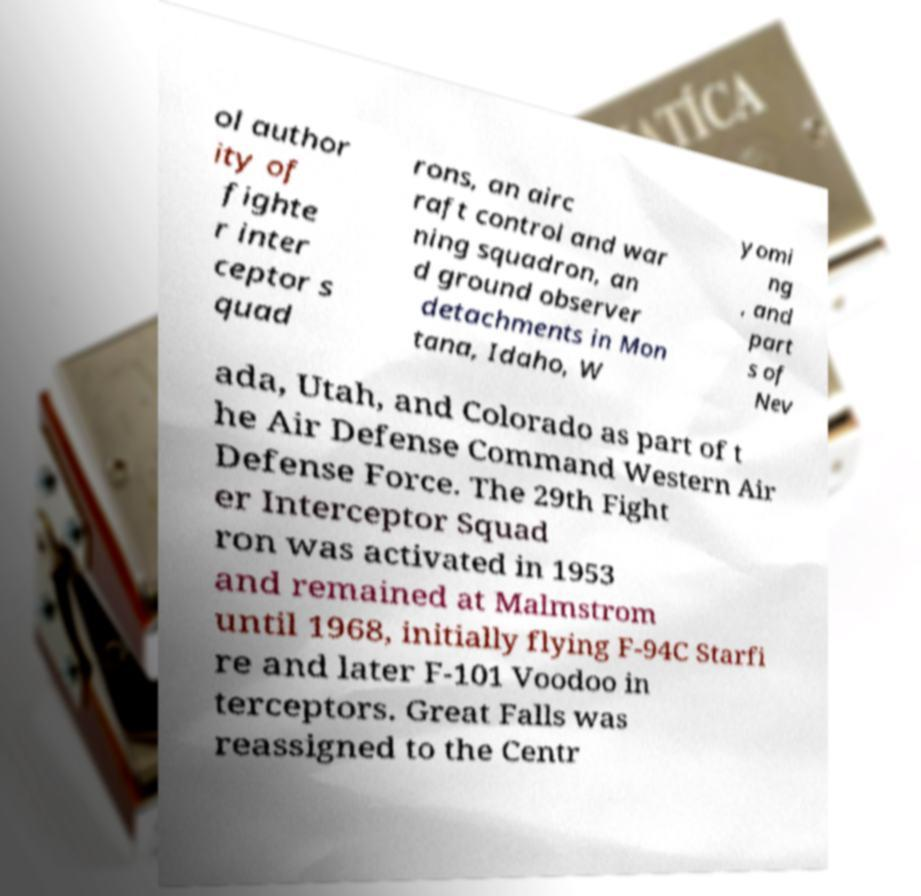What messages or text are displayed in this image? I need them in a readable, typed format. ol author ity of fighte r inter ceptor s quad rons, an airc raft control and war ning squadron, an d ground observer detachments in Mon tana, Idaho, W yomi ng , and part s of Nev ada, Utah, and Colorado as part of t he Air Defense Command Western Air Defense Force. The 29th Fight er Interceptor Squad ron was activated in 1953 and remained at Malmstrom until 1968, initially flying F-94C Starfi re and later F-101 Voodoo in terceptors. Great Falls was reassigned to the Centr 